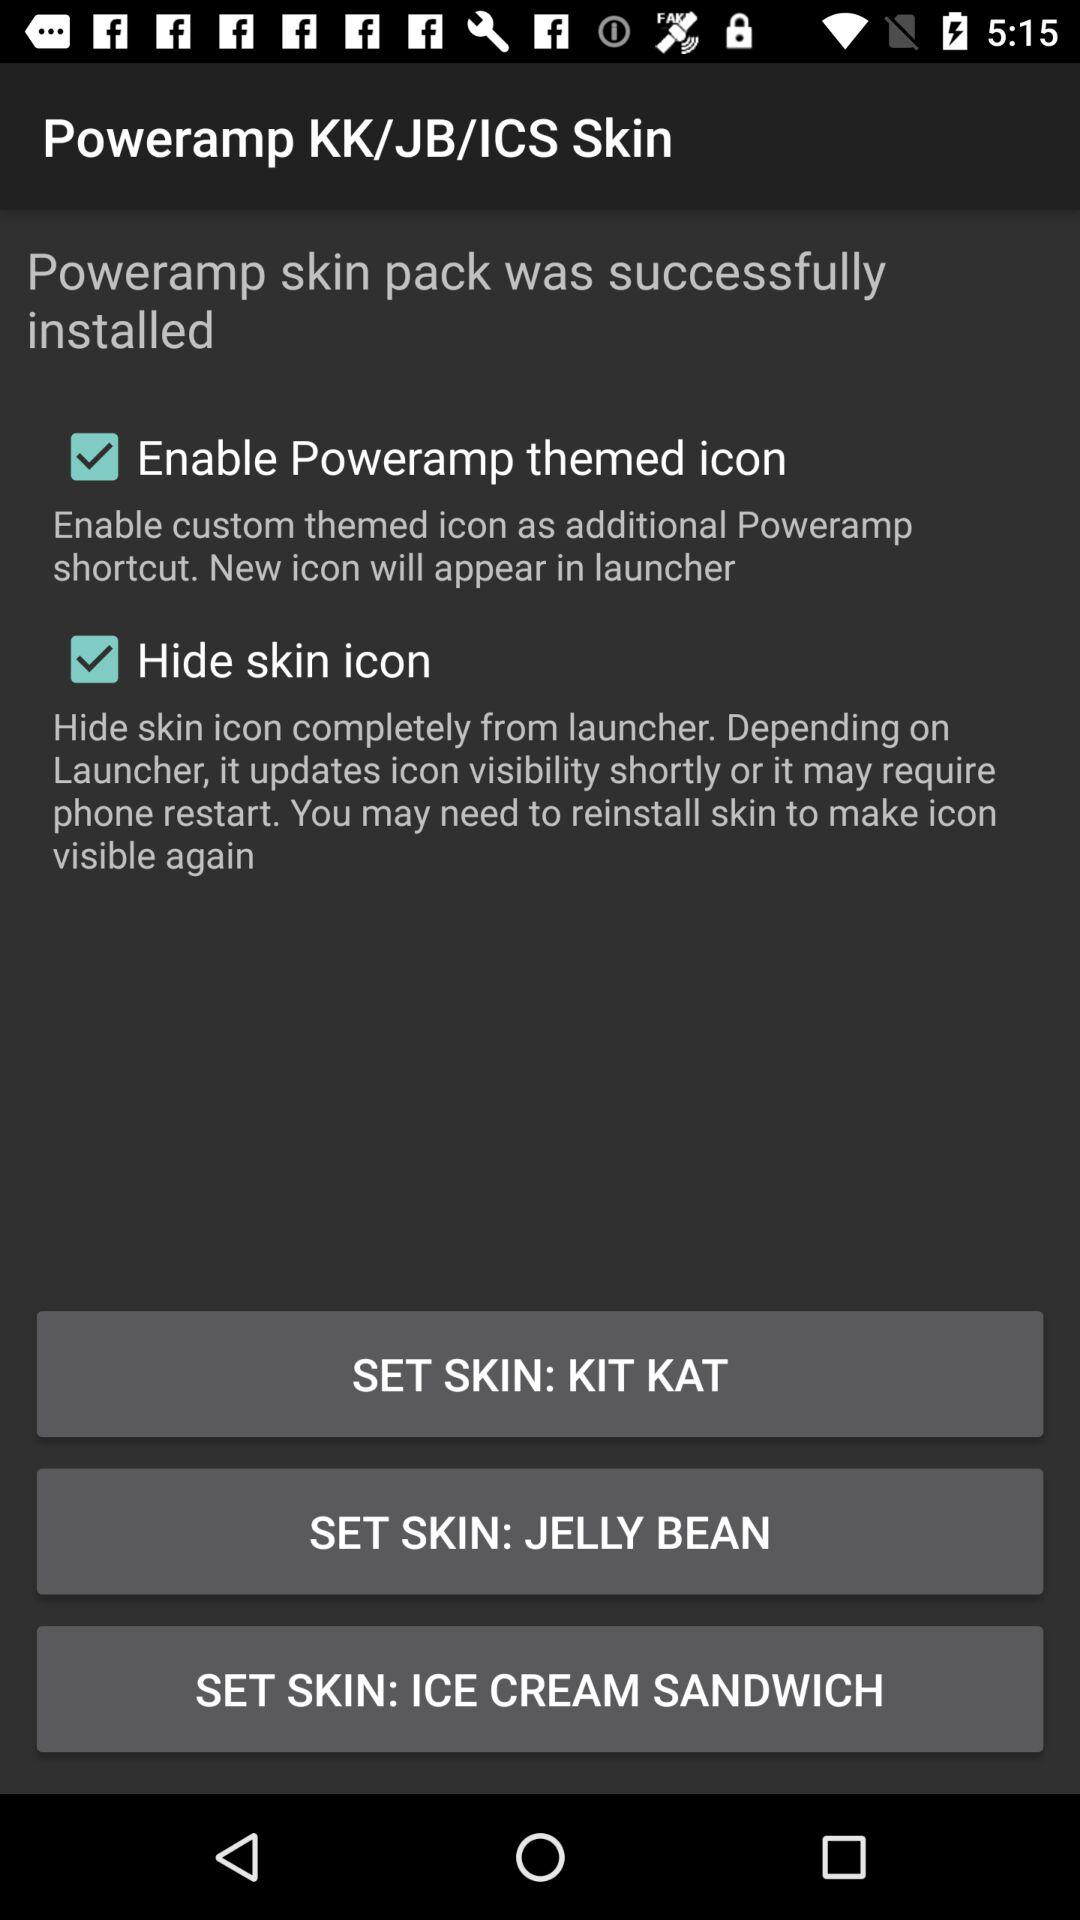What's the selected option? The selected options are "Enable Poweramp themed icon" and "Hide skin icon". 